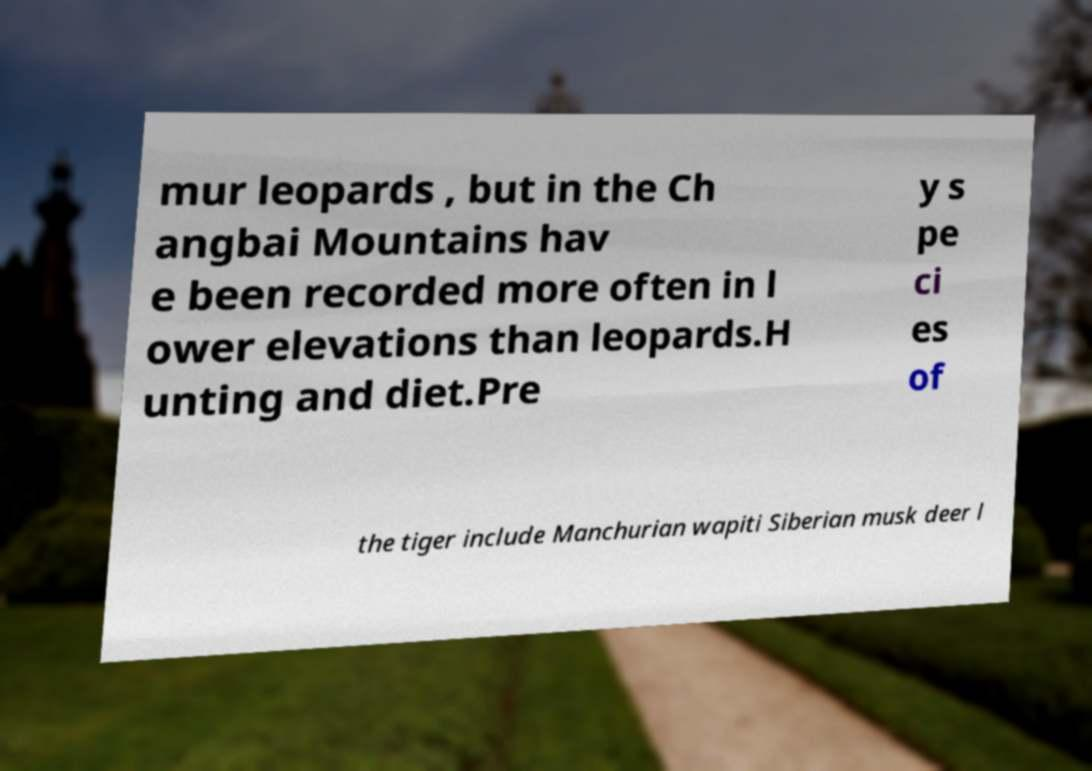Could you extract and type out the text from this image? mur leopards , but in the Ch angbai Mountains hav e been recorded more often in l ower elevations than leopards.H unting and diet.Pre y s pe ci es of the tiger include Manchurian wapiti Siberian musk deer l 